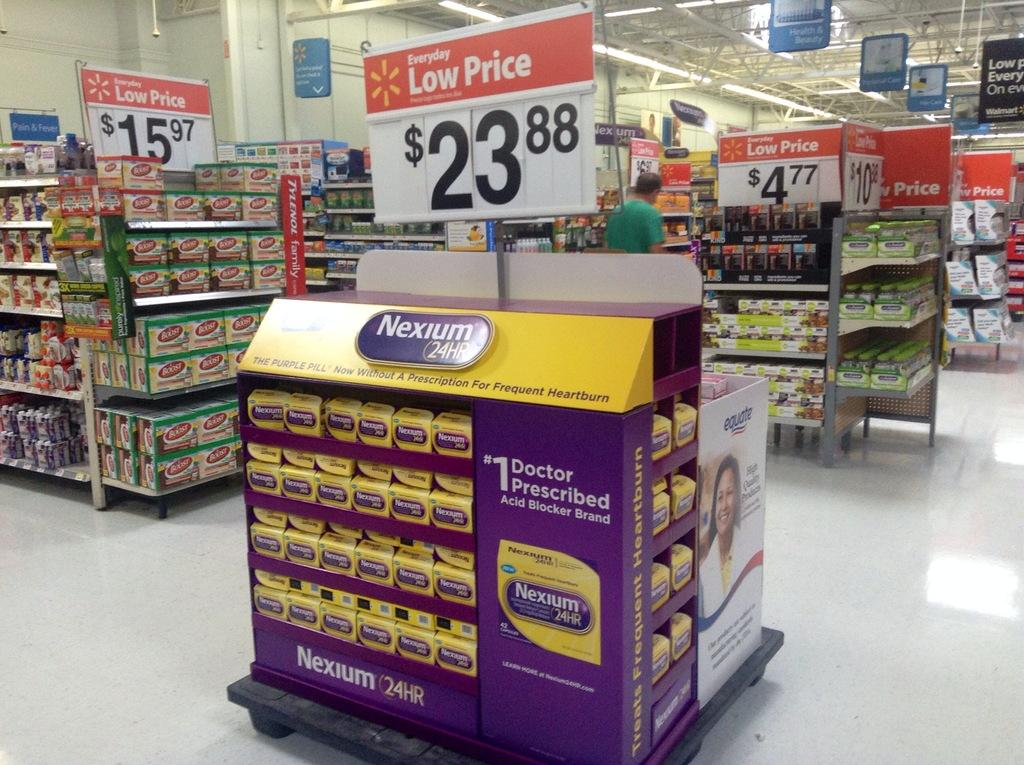<image>
Render a clear and concise summary of the photo. A center aisle store display of Nexium is being advertised for under $24.00. 